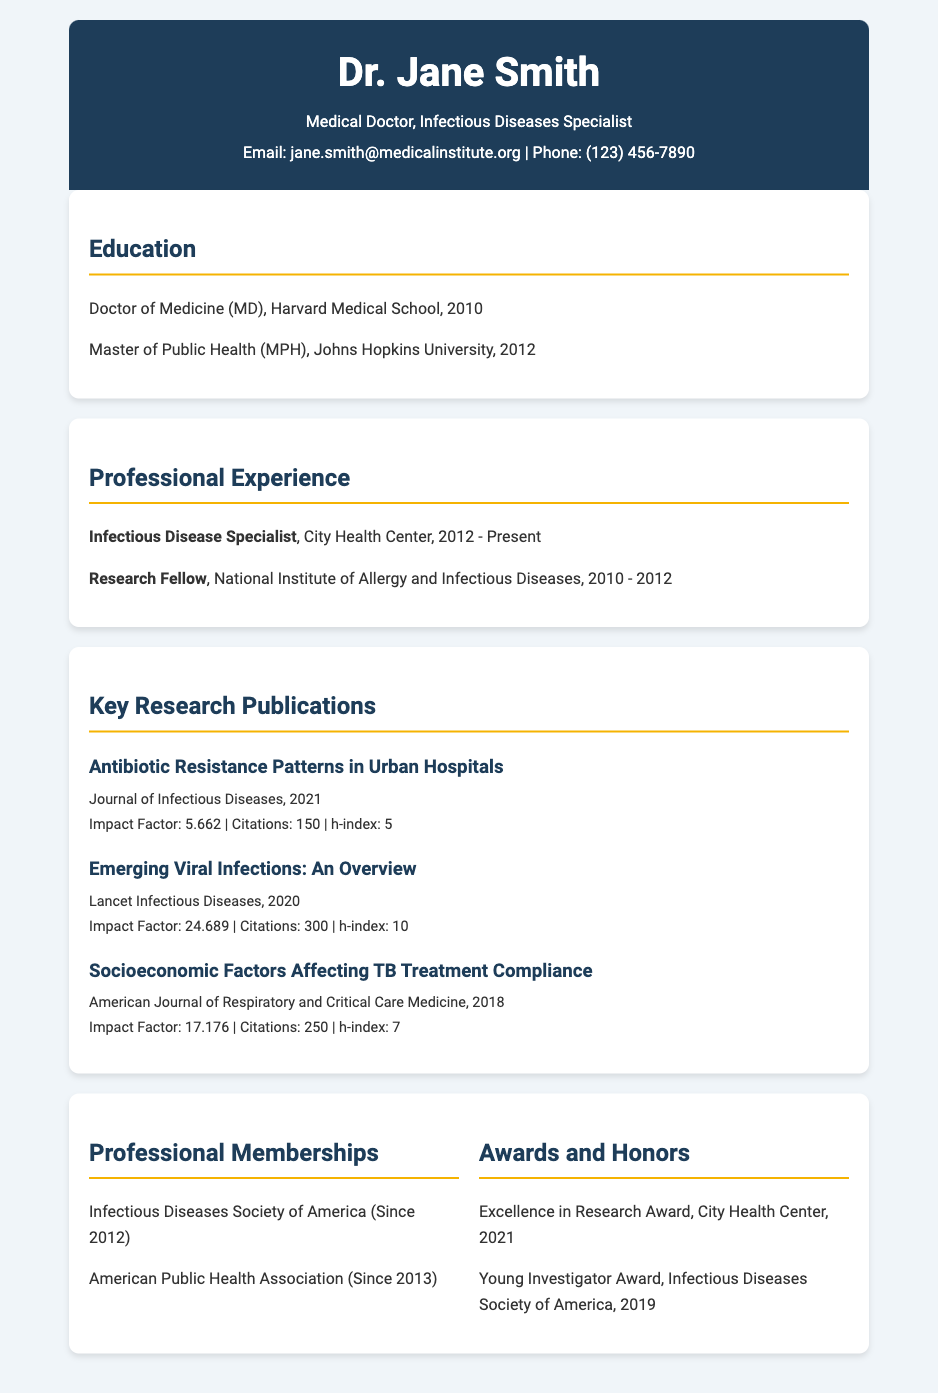what is the name of the specialist? The document includes the header where the name of the specialist is displayed.
Answer: Dr. Jane Smith which journal published the article on Antibiotic Resistance Patterns? The document lists the journal titles for each research publication.
Answer: Journal of Infectious Diseases how many citations does the publication on Emerging Viral Infections have? The document provides citation metrics for each publication.
Answer: 300 what is the impact factor of the publication in 2018? The document lists the impact factors for the research publications by year.
Answer: 17.176 in which year did Dr. Jane Smith receive the Young Investigator Award? The awards section in the document includes the years for each award received.
Answer: 2019 how long has Dr. Jane Smith been a member of the Infectious Diseases Society of America? The document states the year of membership for professional organizations.
Answer: Since 2012 what is Dr. Jane Smith's highest h-index listed? The document includes h-index values for each publication, which can be compared to determine the highest.
Answer: 10 which university did Dr. Jane Smith attend for her Master of Public Health degree? The education section presents the institutions that Dr. Jane Smith attended.
Answer: Johns Hopkins University how many years of professional experience does Dr. Jane Smith have in infectious diseases? The professional experience section indicates the years of service at the City Health Center.
Answer: 11 years 